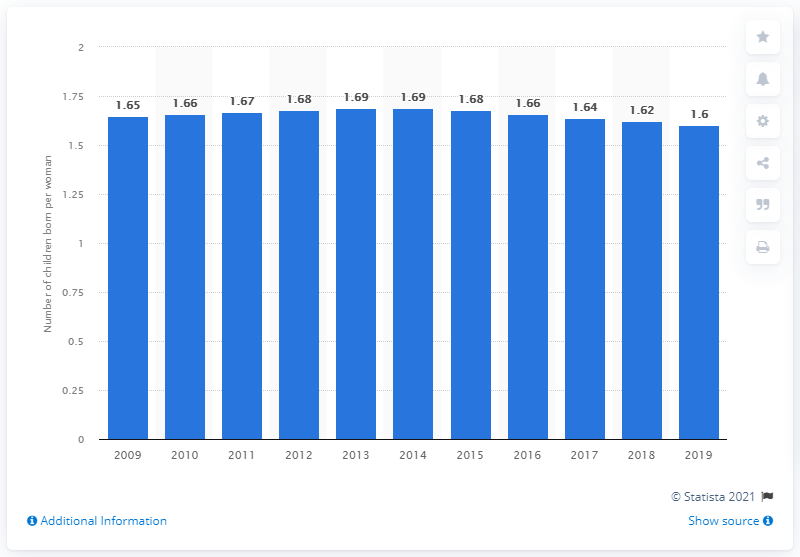Highlight a few significant elements in this photo. The fertility rate in Albania in 2019 was 1.6 children per woman. 